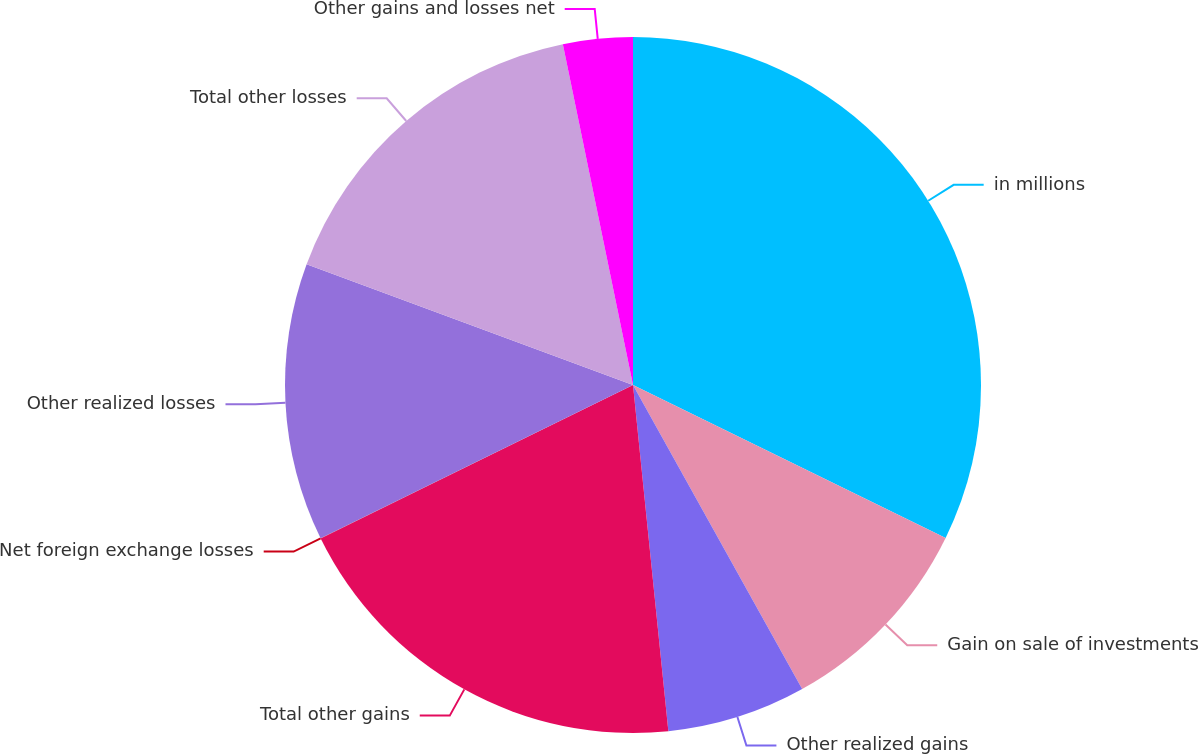Convert chart to OTSL. <chart><loc_0><loc_0><loc_500><loc_500><pie_chart><fcel>in millions<fcel>Gain on sale of investments<fcel>Other realized gains<fcel>Total other gains<fcel>Net foreign exchange losses<fcel>Other realized losses<fcel>Total other losses<fcel>Other gains and losses net<nl><fcel>32.24%<fcel>9.68%<fcel>6.46%<fcel>19.35%<fcel>0.01%<fcel>12.9%<fcel>16.13%<fcel>3.23%<nl></chart> 